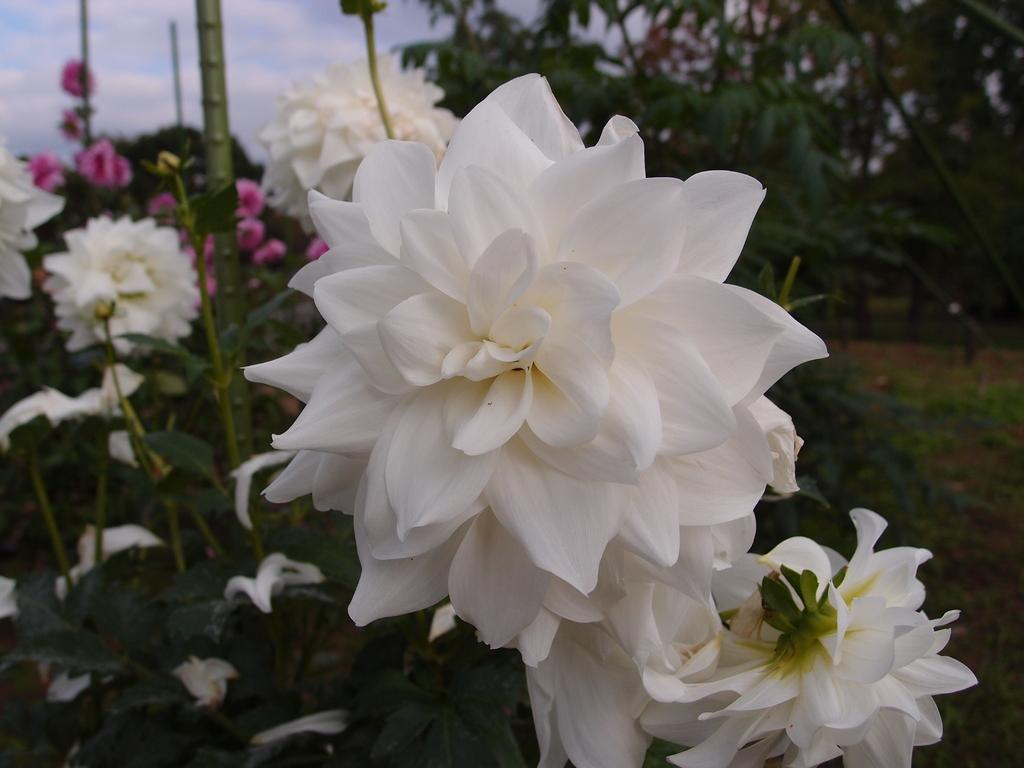What types of flowers are present in the image? There are white and pink flowers in the image. Where are the flowers located? The flowers are on plants. What can be seen in the background of the image? There are trees and the sky visible in the background of the image. What type of locket can be seen hanging from the tree in the image? There is no locket present in the image; it features white and pink flowers on plants, with trees and the sky visible in the background. 